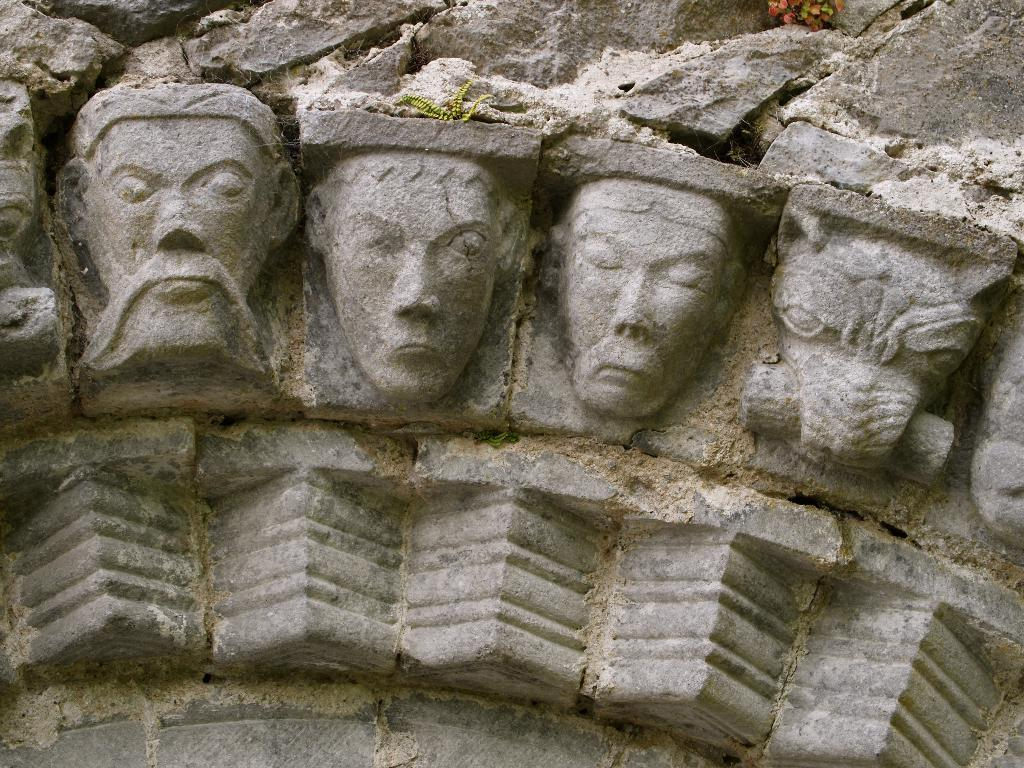What type of artwork can be seen on the wall in the image? There are sculptures on the wall in the image. What type of pump is being used by the minister in the image? There is no minister or pump present in the image; it features sculptures on the wall. What color is the ball that the sculptures are playing with in the image? There is no ball present in the image; it features sculptures on the wall. 